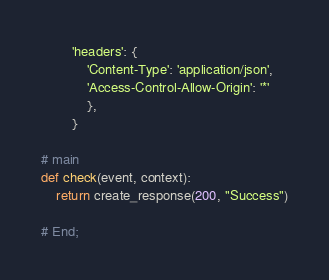Convert code to text. <code><loc_0><loc_0><loc_500><loc_500><_Python_>        'headers': {
            'Content-Type': 'application/json',
            'Access-Control-Allow-Origin': '*'
            },
        }

# main
def check(event, context):
    return create_response(200, "Success")

# End;</code> 